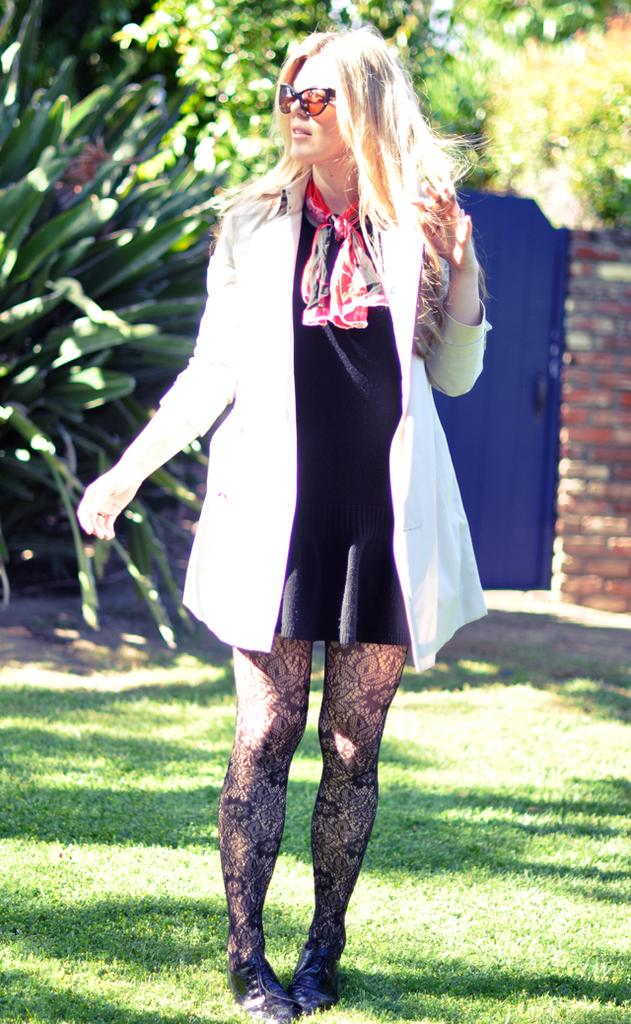What is the person in the image wearing? The person in the image is wearing a black and white dress. What can be seen in the background of the image? There are trees, a wall, and a blue color object in the background of the image. Can you tell me where the hen is located in the image? There is no hen present in the image. What type of cracker is being used as a prop in the image? There is no cracker present in the image. 